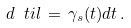<formula> <loc_0><loc_0><loc_500><loc_500>d \ t i l \, = \, \gamma _ { s } ( t ) d t \, .</formula> 